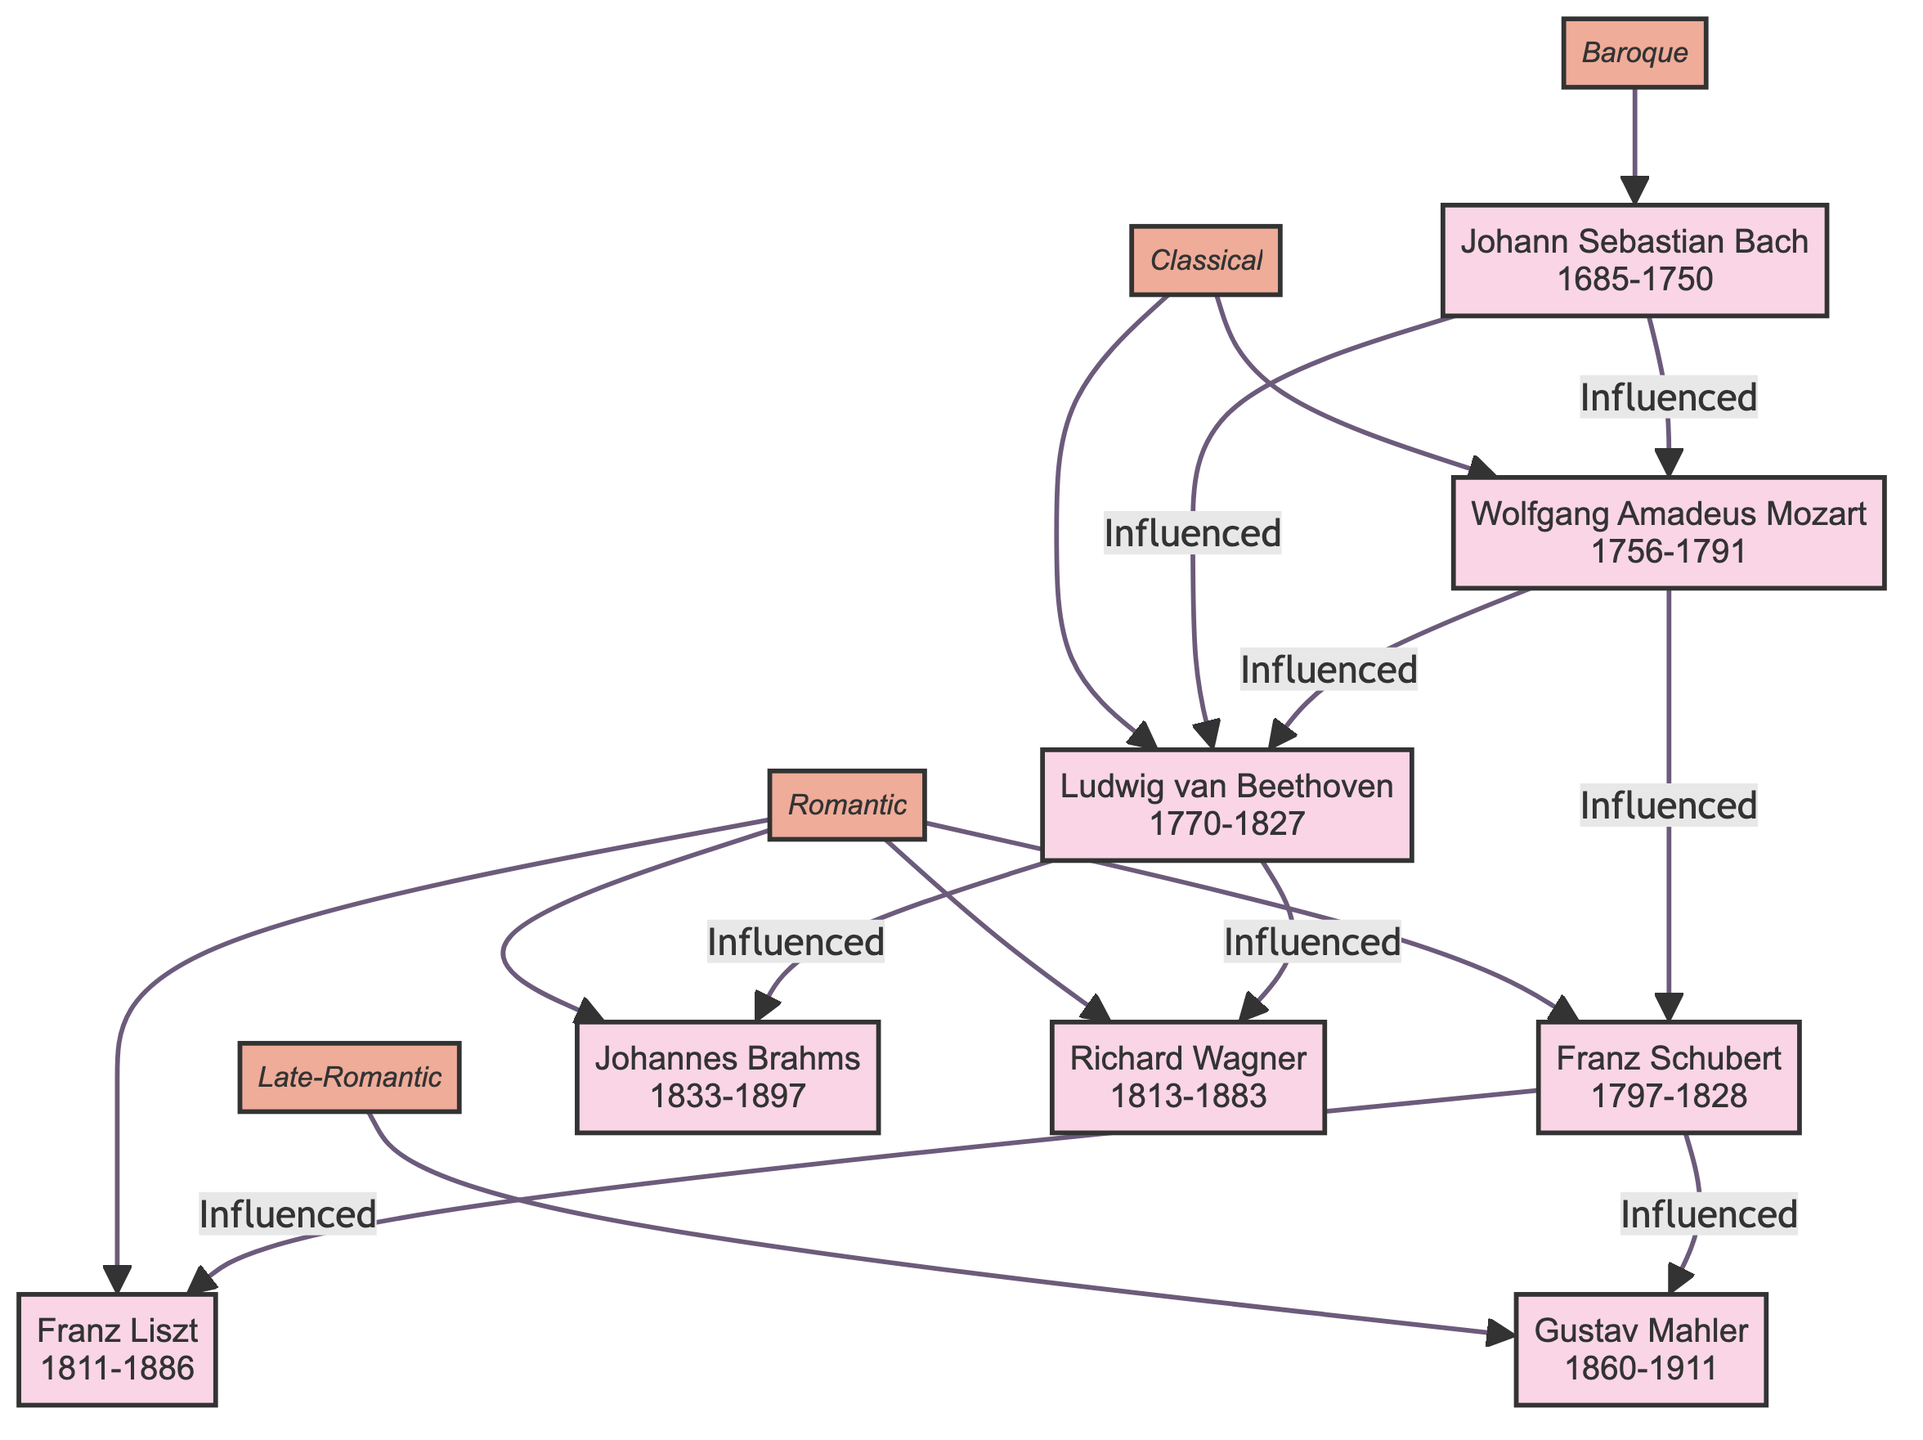What is the birth year of Wolfgang Amadeus Mozart? The diagram indicates that Wolfgang Amadeus Mozart was born in 1756.
Answer: 1756 Who is the composer influenced by both Johann Sebastian Bach and Wolfgang Amadeus Mozart? According to the diagram, Ludwig van Beethoven is influenced by both Johann Sebastian Bach and Wolfgang Amadeus Mozart.
Answer: Ludwig van Beethoven How many composers are listed in the diagram? The diagram shows a total of eight composers: Bach, Mozart, Beethoven, Schubert, Brahms, Wagner, Liszt, and Mahler.
Answer: 8 Which composer listed has a style of Late-Romantic? The diagram shows that Gustav Mahler is categorized as a Late-Romantic composer.
Answer: Gustav Mahler What is the relation between Franz Schubert and Franz Liszt? The diagram indicates that Franz Schubert influenced Franz Liszt directly.
Answer: Influenced Who influenced Brahms? The diagram does not show any influences on Johannes Brahms, implying he is not influenced by any composer listed.
Answer: None Which era does Richard Wagner belong to? The diagram indicates that Richard Wagner is classified under the Romantic era.
Answer: Romantic Name one key work by Johann Sebastian Bach. The diagram lists "Brandenburg Concertos" and "The Well-Tempered Clavier" as key works of Johann Sebastian Bach.
Answer: Brandenburg Concertos 